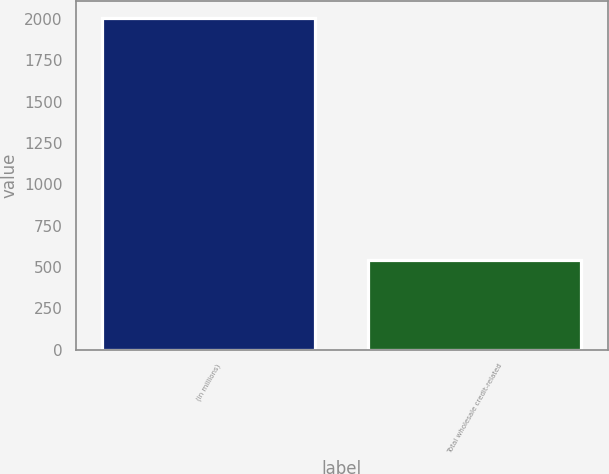Convert chart to OTSL. <chart><loc_0><loc_0><loc_500><loc_500><bar_chart><fcel>(in millions)<fcel>Total wholesale credit-related<nl><fcel>2007<fcel>543<nl></chart> 